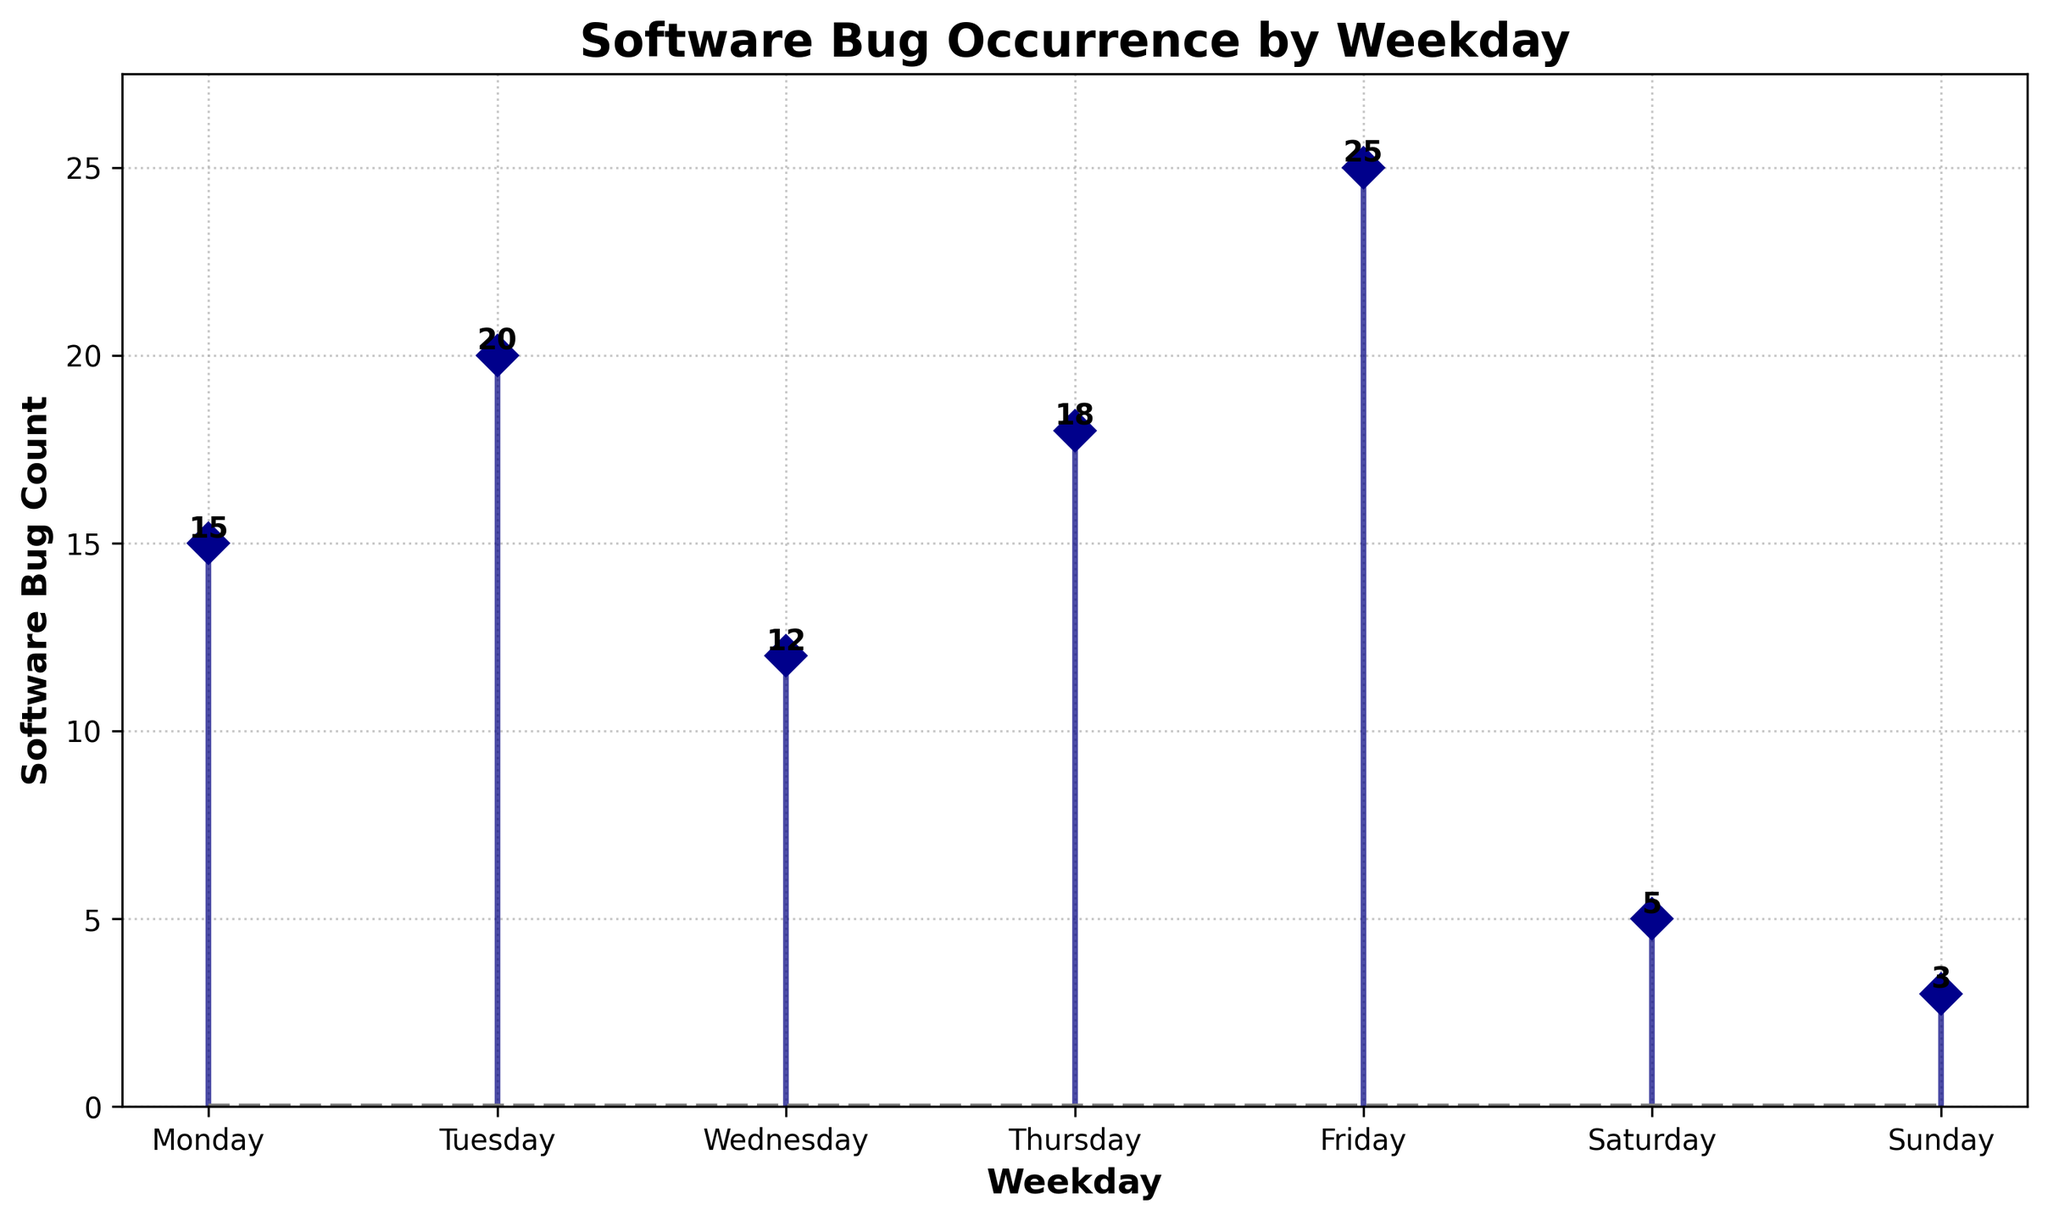What's the title of this plot? The title is located at the top of the plot and is clearly labeled.
Answer: Software Bug Occurrence by Weekday How many weekdays are shown? The x-axis displays the days of the week, from Monday to Sunday. Counting these labels gives 7 days.
Answer: 7 Which weekday has the highest number of software bugs? The y-values indicate the bug count for each weekday. The tallest stem is above Friday at a count of 25.
Answer: Friday What is the software bug count on Saturday? Looking at the stem for Saturday, the height of the stem and the labeled number above indicate the count.
Answer: 5 Are there more bugs on Wednesday or Thursday? Comparing the heights of the stems for Wednesday and Thursday, Thursday's stem is higher.
Answer: Thursday What are the total software bugs from Monday to Wednesday? Summing the counts for Monday (15), Tuesday (20), and Wednesday (12): 15 + 20 + 12 = 47.
Answer: 47 What is the difference in bug counts between Friday and Sunday? Subtract the bug count on Sunday (3) from Friday (25): 25 - 3 = 22.
Answer: 22 Which two weekdays have the same software bug count? By examining the stems, none of the days have the same height.
Answer: None How does the bug count trend from Monday to Wednesday? Observing the stems, the bug count increases from Monday (15) to Tuesday (20) and then decreases to Wednesday (12).
Answer: Increase then decrease 